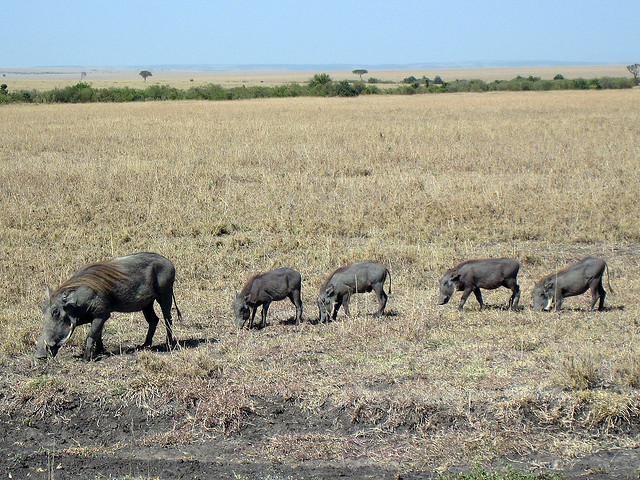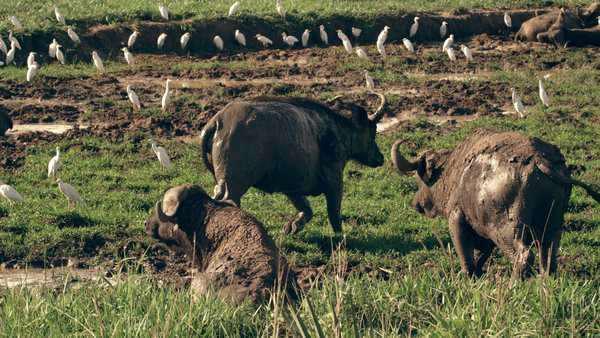The first image is the image on the left, the second image is the image on the right. Assess this claim about the two images: "There is a group of warthogs by the water.". Correct or not? Answer yes or no. No. The first image is the image on the left, the second image is the image on the right. Given the left and right images, does the statement "An image shows a water source for warthogs." hold true? Answer yes or no. No. 